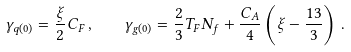<formula> <loc_0><loc_0><loc_500><loc_500>\gamma _ { q ( 0 ) } = \frac { \xi } { 2 } C _ { F } \, , \quad \gamma _ { g ( 0 ) } = \frac { 2 } { 3 } T _ { F } N _ { f } + \frac { C _ { A } } { 4 } \left ( \xi - \frac { 1 3 } { 3 } \right ) \, .</formula> 